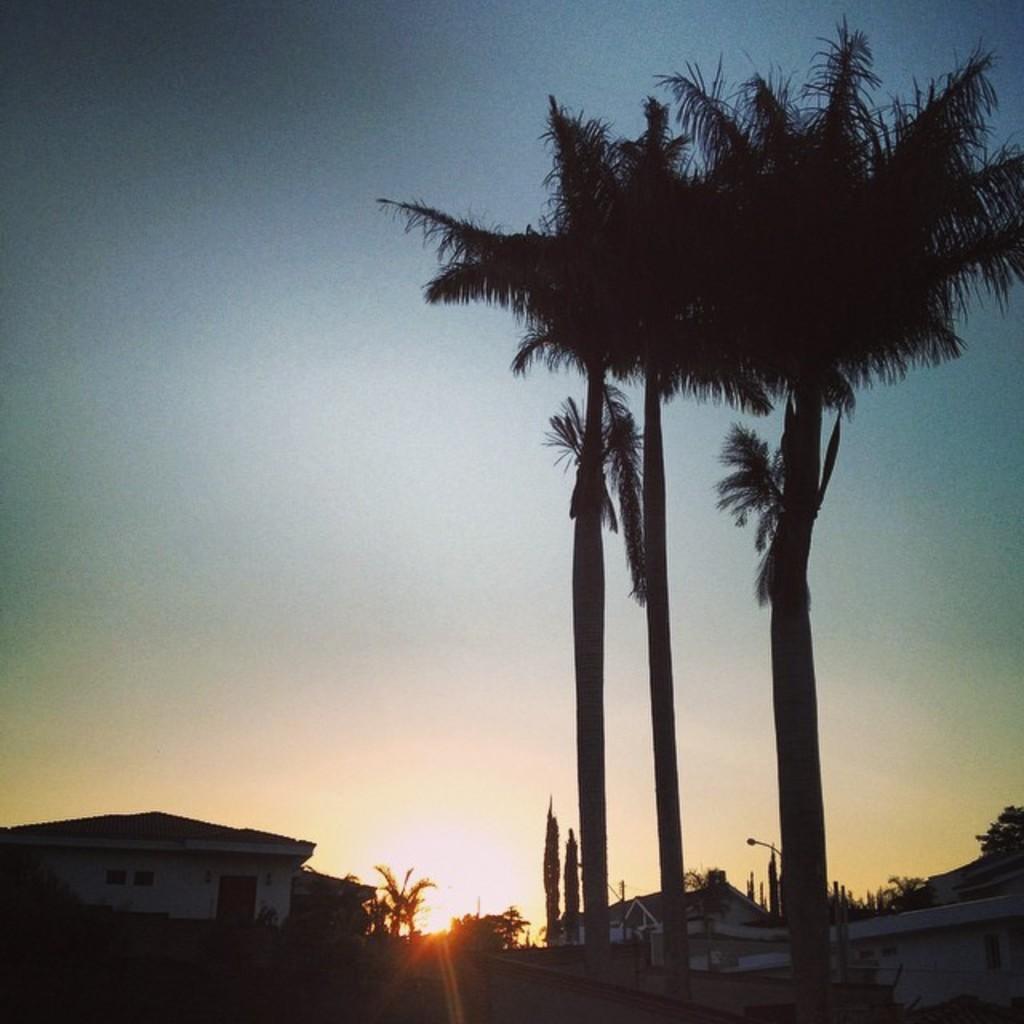Could you give a brief overview of what you see in this image? In the picture I can see trees, houses, a street light and some other objects. In the background I can see the sky and the sun. 